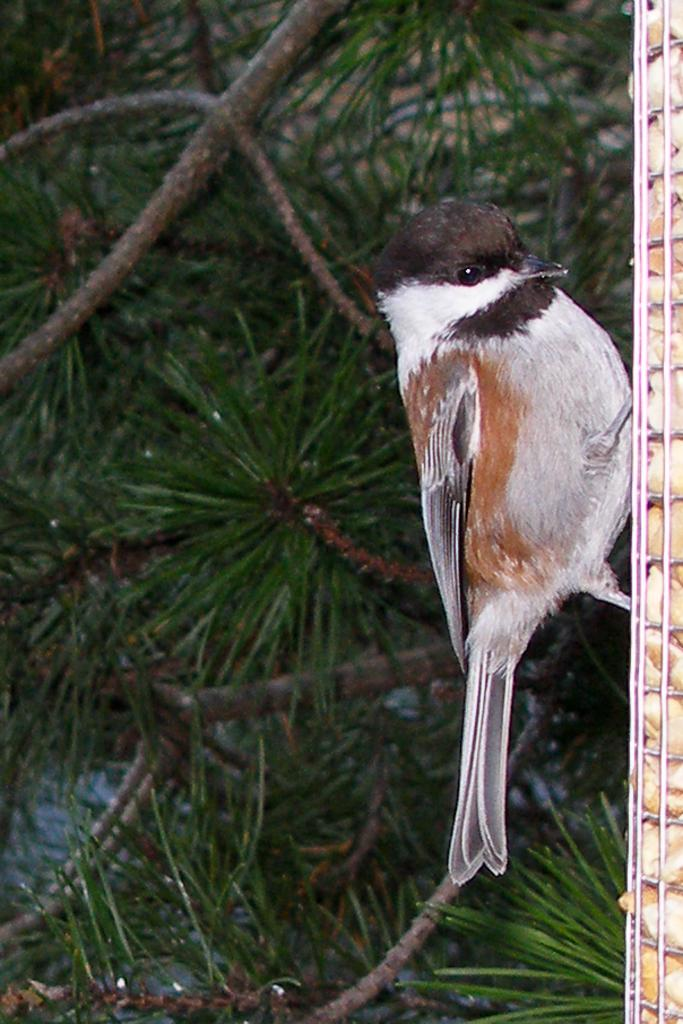What type of animal can be seen in the image? There is a bird in the image. What can be seen in the background of the image? There are branches with leaves in the background of the image. What type of lunch is the bird eating in the image? There is no lunch present in the image; it only shows a bird and branches with leaves. 